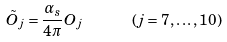Convert formula to latex. <formula><loc_0><loc_0><loc_500><loc_500>\tilde { O } _ { j } = \frac { \alpha _ { s } } { 4 \pi } O _ { j } \, \ \, \ \, \ \, \ \, \ ( j = 7 , \dots , 1 0 )</formula> 